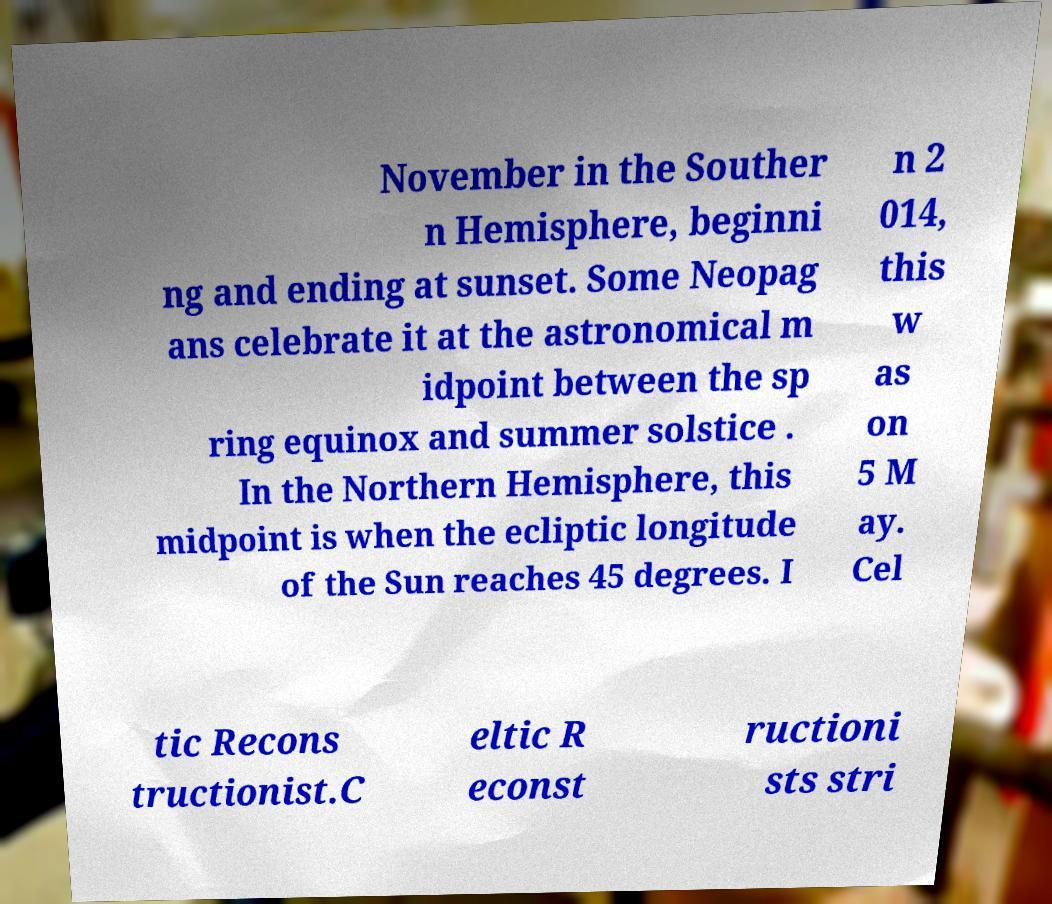Can you accurately transcribe the text from the provided image for me? November in the Souther n Hemisphere, beginni ng and ending at sunset. Some Neopag ans celebrate it at the astronomical m idpoint between the sp ring equinox and summer solstice . In the Northern Hemisphere, this midpoint is when the ecliptic longitude of the Sun reaches 45 degrees. I n 2 014, this w as on 5 M ay. Cel tic Recons tructionist.C eltic R econst ructioni sts stri 